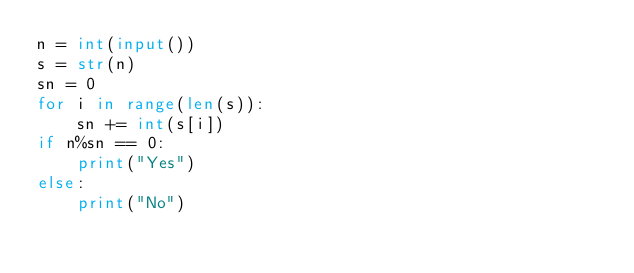Convert code to text. <code><loc_0><loc_0><loc_500><loc_500><_Python_>n = int(input())
s = str(n)
sn = 0
for i in range(len(s)):
    sn += int(s[i])
if n%sn == 0:
    print("Yes")
else:
    print("No")</code> 